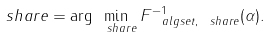Convert formula to latex. <formula><loc_0><loc_0><loc_500><loc_500>\ s h a r e = \arg \min _ { \ s h a r e } F _ { \ a l g s e t , \ s h a r e } ^ { - 1 } ( \alpha ) .</formula> 